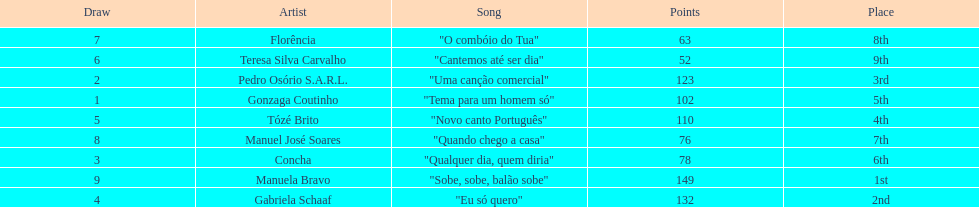Who was the last draw? Manuela Bravo. 